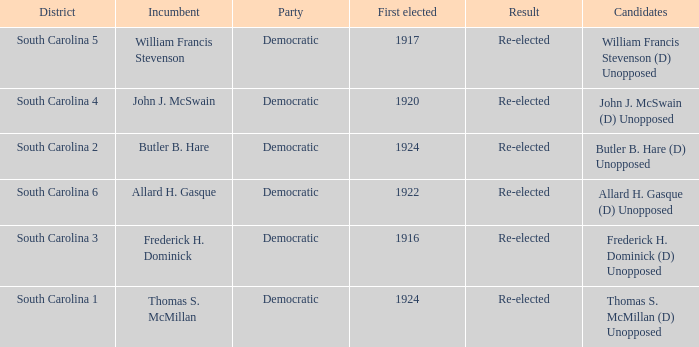What is the total number of results where the district is south carolina 5? 1.0. Help me parse the entirety of this table. {'header': ['District', 'Incumbent', 'Party', 'First elected', 'Result', 'Candidates'], 'rows': [['South Carolina 5', 'William Francis Stevenson', 'Democratic', '1917', 'Re-elected', 'William Francis Stevenson (D) Unopposed'], ['South Carolina 4', 'John J. McSwain', 'Democratic', '1920', 'Re-elected', 'John J. McSwain (D) Unopposed'], ['South Carolina 2', 'Butler B. Hare', 'Democratic', '1924', 'Re-elected', 'Butler B. Hare (D) Unopposed'], ['South Carolina 6', 'Allard H. Gasque', 'Democratic', '1922', 'Re-elected', 'Allard H. Gasque (D) Unopposed'], ['South Carolina 3', 'Frederick H. Dominick', 'Democratic', '1916', 'Re-elected', 'Frederick H. Dominick (D) Unopposed'], ['South Carolina 1', 'Thomas S. McMillan', 'Democratic', '1924', 'Re-elected', 'Thomas S. McMillan (D) Unopposed']]} 